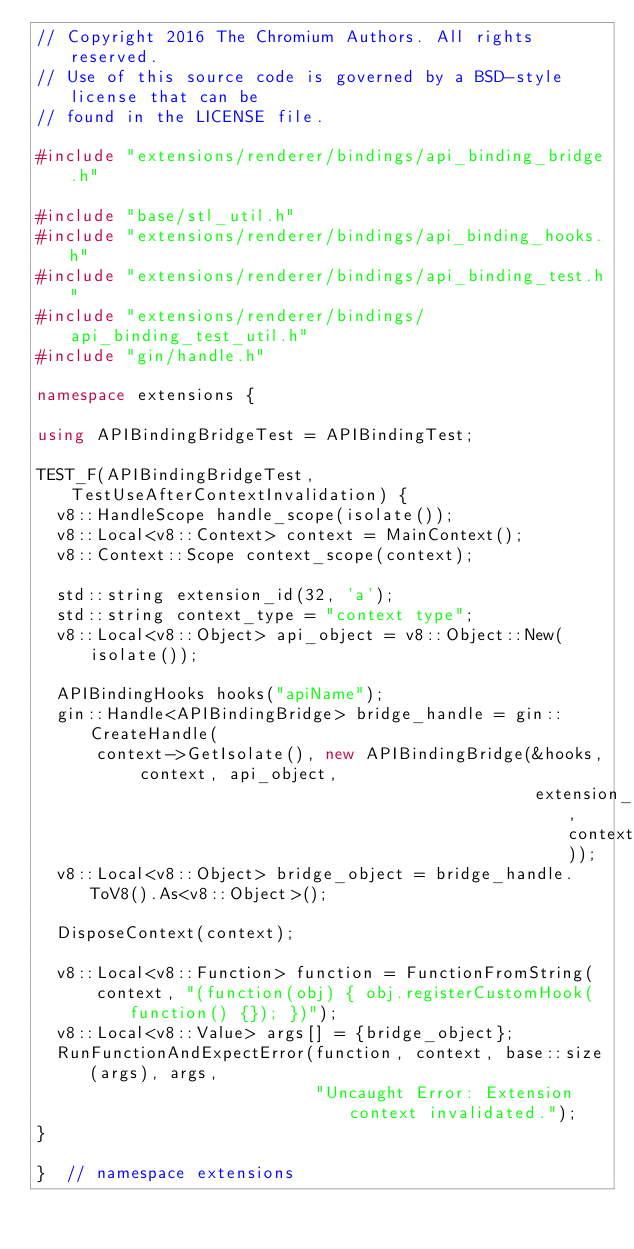Convert code to text. <code><loc_0><loc_0><loc_500><loc_500><_C++_>// Copyright 2016 The Chromium Authors. All rights reserved.
// Use of this source code is governed by a BSD-style license that can be
// found in the LICENSE file.

#include "extensions/renderer/bindings/api_binding_bridge.h"

#include "base/stl_util.h"
#include "extensions/renderer/bindings/api_binding_hooks.h"
#include "extensions/renderer/bindings/api_binding_test.h"
#include "extensions/renderer/bindings/api_binding_test_util.h"
#include "gin/handle.h"

namespace extensions {

using APIBindingBridgeTest = APIBindingTest;

TEST_F(APIBindingBridgeTest, TestUseAfterContextInvalidation) {
  v8::HandleScope handle_scope(isolate());
  v8::Local<v8::Context> context = MainContext();
  v8::Context::Scope context_scope(context);

  std::string extension_id(32, 'a');
  std::string context_type = "context type";
  v8::Local<v8::Object> api_object = v8::Object::New(isolate());

  APIBindingHooks hooks("apiName");
  gin::Handle<APIBindingBridge> bridge_handle = gin::CreateHandle(
      context->GetIsolate(), new APIBindingBridge(&hooks, context, api_object,
                                                  extension_id, context_type));
  v8::Local<v8::Object> bridge_object = bridge_handle.ToV8().As<v8::Object>();

  DisposeContext(context);

  v8::Local<v8::Function> function = FunctionFromString(
      context, "(function(obj) { obj.registerCustomHook(function() {}); })");
  v8::Local<v8::Value> args[] = {bridge_object};
  RunFunctionAndExpectError(function, context, base::size(args), args,
                            "Uncaught Error: Extension context invalidated.");
}

}  // namespace extensions
</code> 